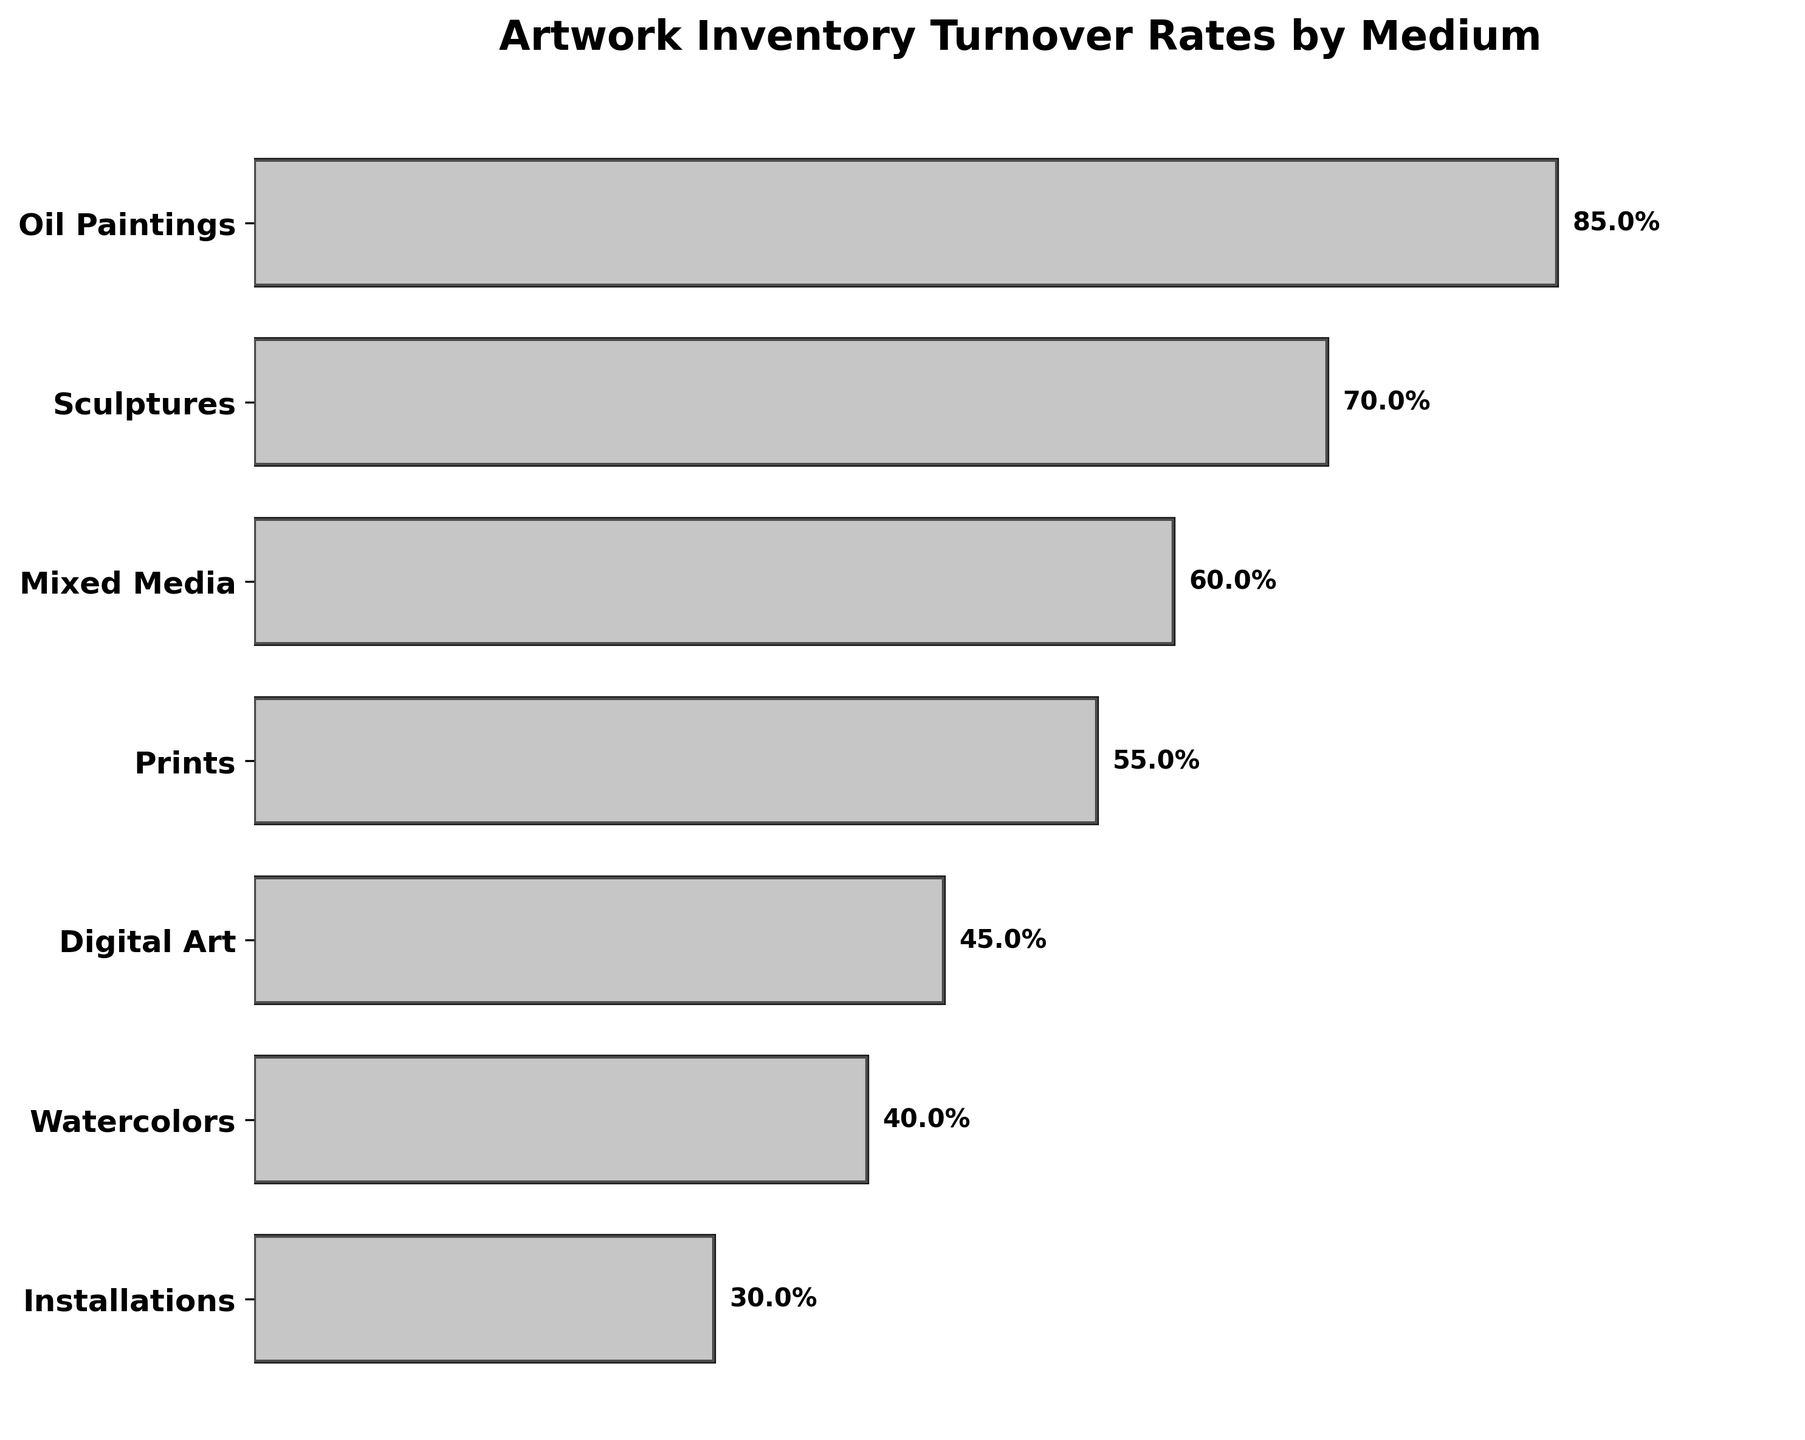what is the turnover rate for watercolors? Look at the bar corresponding to "Watercolors" on the y-axis and read the percentage label next to it. It shows the turnover rate for watercolors as 40%.
Answer: 40% How many different artwork mediums are included in the chart? Count the number of unique medium labels on the y-axis from top to bottom. There are seven labeled mediums: Oil Paintings, Sculptures, Mixed Media, Prints, Digital Art, Watercolors, and Installations.
Answer: 7 Which artwork medium has the highest turnover rate? Identify the bar with the largest percentage label next to it on the x-axis. The "Oil Paintings" bar has the highest turnover rate at 85%.
Answer: Oil Paintings By how much is the turnover rate for Oil Paintings higher than Watercolors? Subtract the turnover rate of Watercolors (40%) from that of Oil Paintings (85%). The difference is 45%.
Answer: 45% Rank the artwork mediums from highest to lowest turnover rate. List the mediums in descending order based on their turnover percentage values: Oil Paintings (85%), Sculptures (70%), Mixed Media (60%), Prints (55%), Digital Art (45%), Watercolors (40%), Installations (30%).
Answer: Oil Paintings, Sculptures, Mixed Media, Prints, Digital Art, Watercolors, Installations What is the average turnover rate of all the artwork mediums? Add all the turnover rates together (85% + 70% + 60% + 55% + 45% + 40% + 30%) and divide by the number of mediums (7). (85 + 70 + 60 + 55 + 45 + 40 + 30) / 7 = 55%.
Answer: 55% Which medium has a turnover rate closest to the average turnover rate? Calculate the average turnover rate as 55%. Find the medium whose rate is closest to 55%. Prints have a turnover rate of 55%, which exactly matches the average.
Answer: Prints Which artwork medium has a turnover rate less than half that of Oil Paintings? Identify the medium whose turnover rate is less than half of Oil Paintings' rate (85% / 2 = 42.5%). Installations (30%) is the only medium with a rate less than 42.5%.
Answer: Installations What is the difference in turnover rate between Sculptures and Prints? Subtract the turnover rate of Prints (55%) from that of Sculptures (70%). The difference is 15%.
Answer: 15% What proportion of the artwork mediums have a turnover rate of 50% or higher? Count the number of mediums with turnover rates 50% or higher: Oil Paintings (85%), Sculptures (70%), Mixed Media (60%), Prints (55%). There are 4 such mediums out of a total of 7. The proportion is 4/7.
Answer: 4/7 